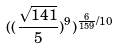<formula> <loc_0><loc_0><loc_500><loc_500>( ( \frac { \sqrt { 1 4 1 } } { 5 } ) ^ { 9 } ) ^ { \frac { 6 } { 1 5 9 } / 1 0 }</formula> 